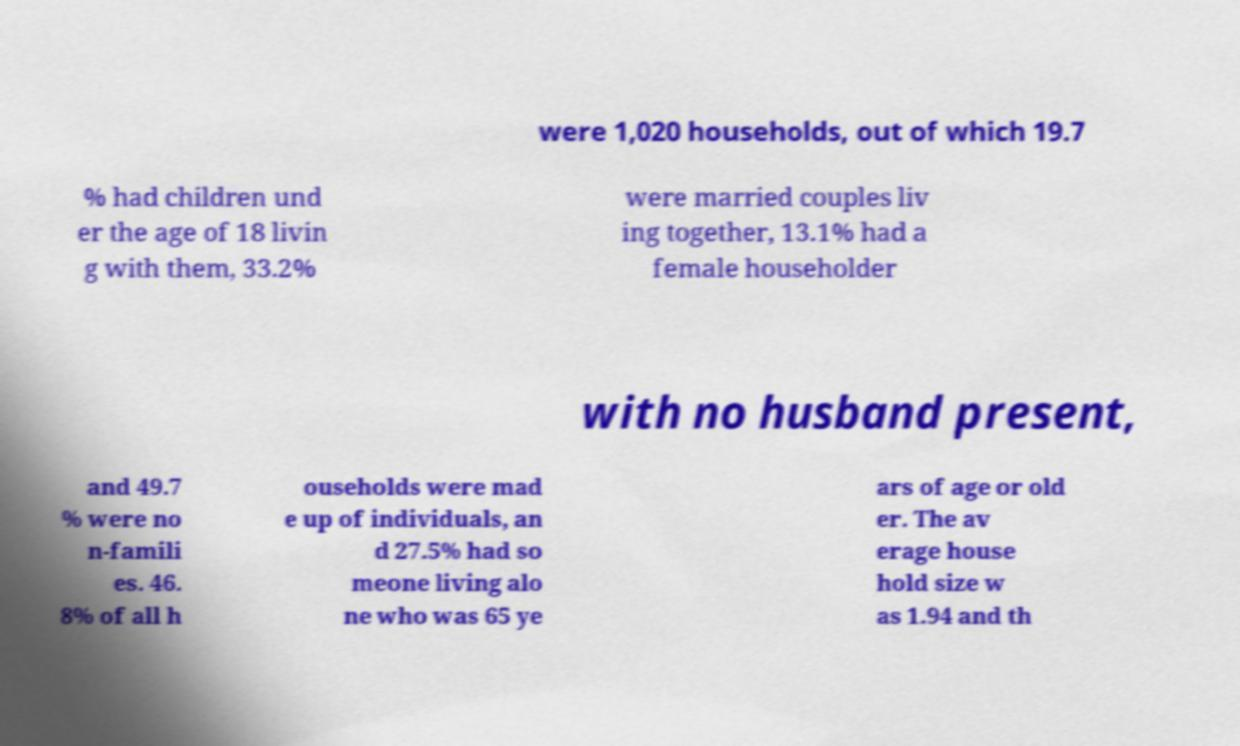What messages or text are displayed in this image? I need them in a readable, typed format. were 1,020 households, out of which 19.7 % had children und er the age of 18 livin g with them, 33.2% were married couples liv ing together, 13.1% had a female householder with no husband present, and 49.7 % were no n-famili es. 46. 8% of all h ouseholds were mad e up of individuals, an d 27.5% had so meone living alo ne who was 65 ye ars of age or old er. The av erage house hold size w as 1.94 and th 